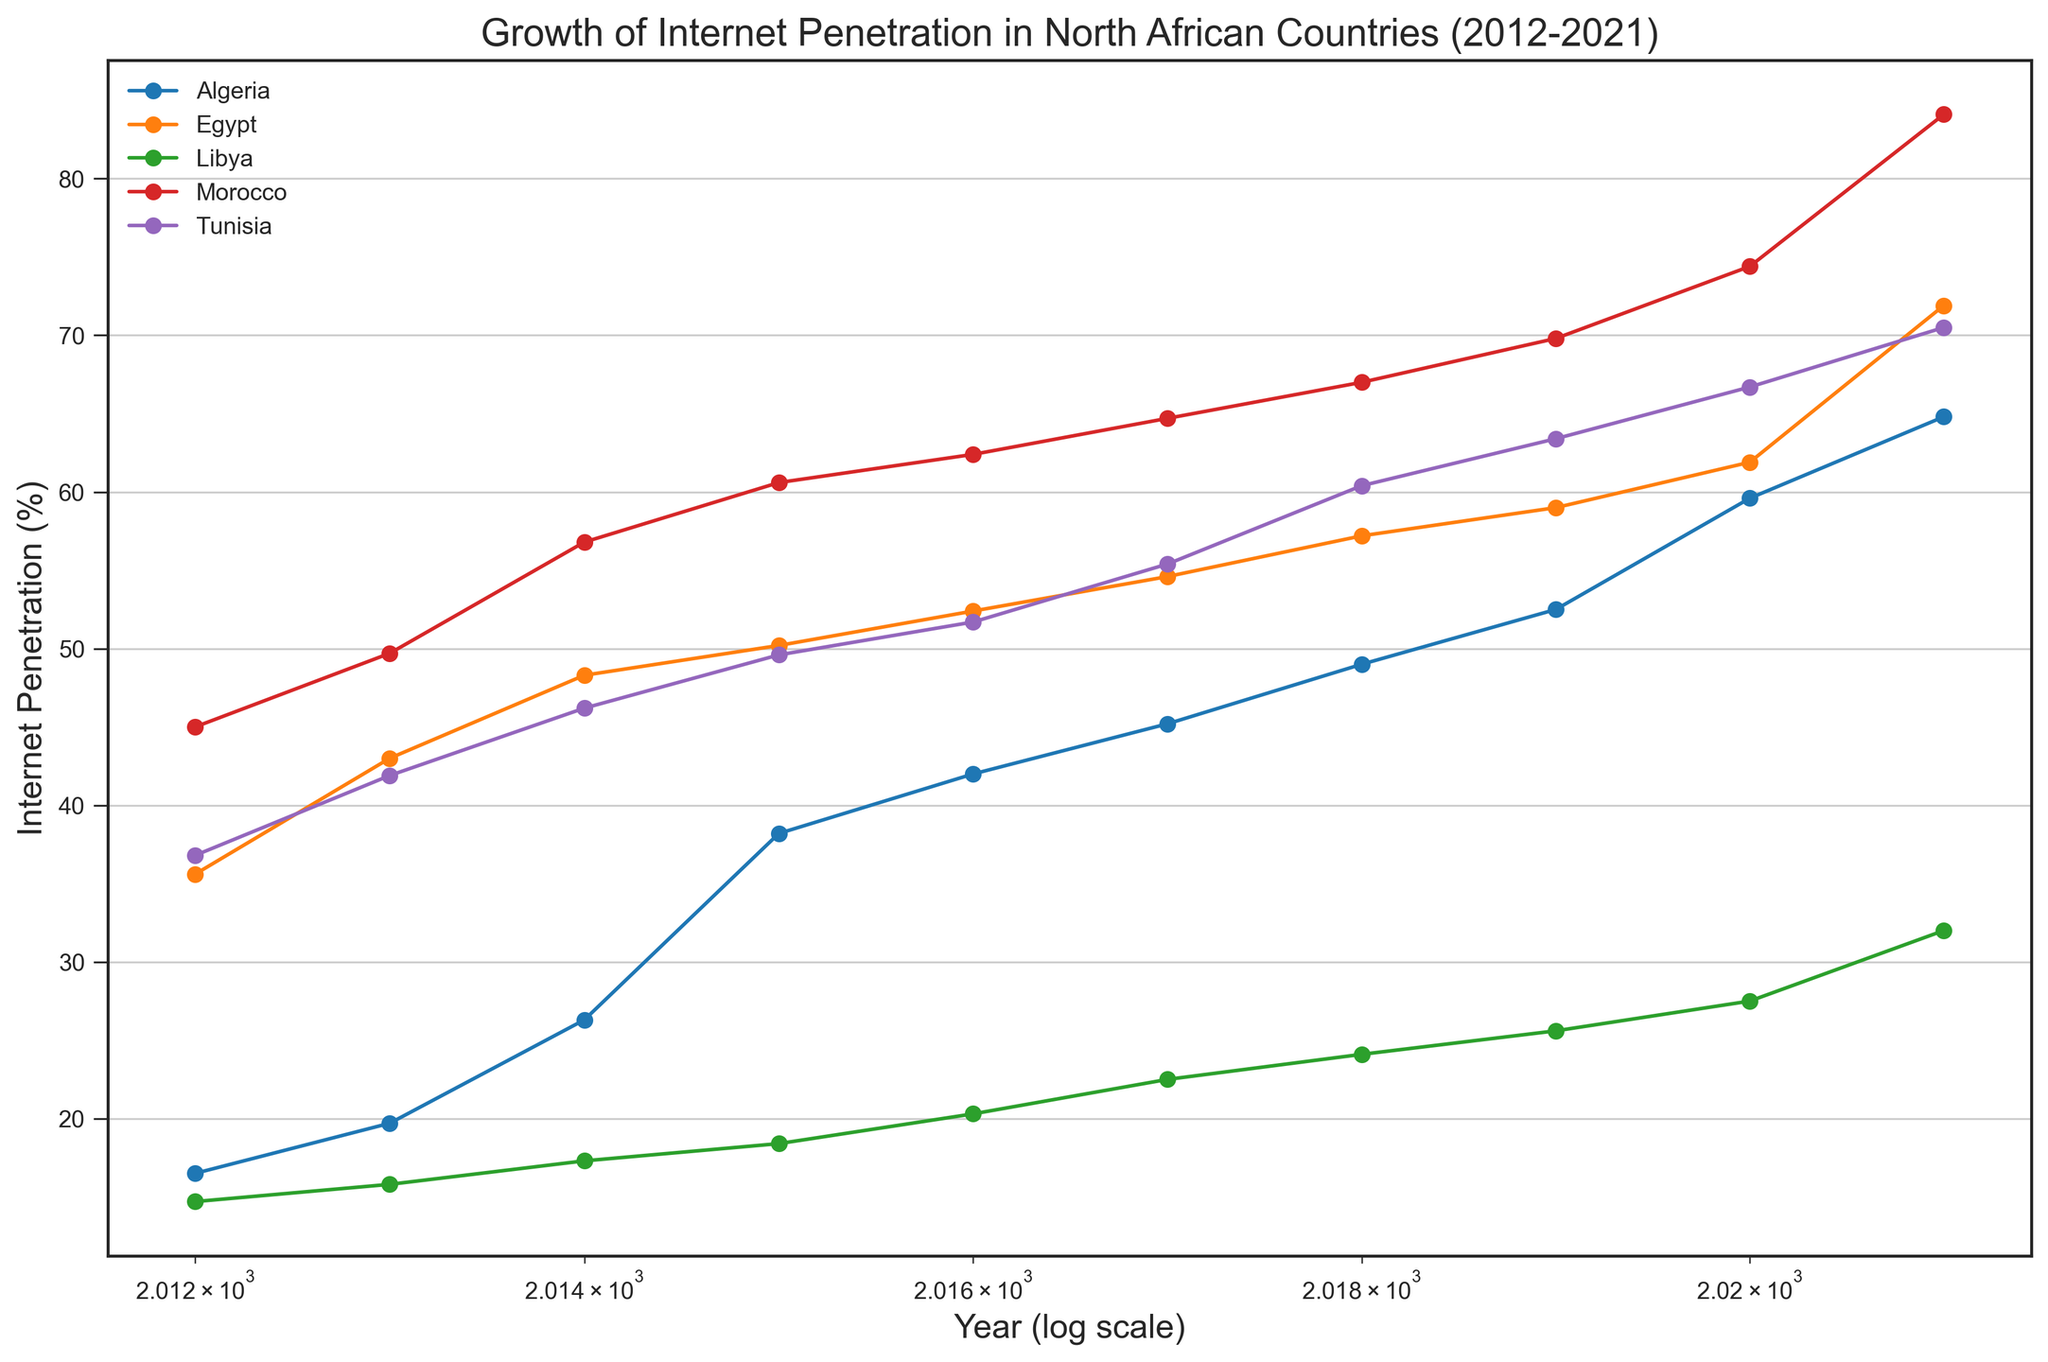Which country had the highest internet penetration percentage in 2021? Look for the country with the highest data point in 2021. According to the figure, the highest internet penetration percentage in 2021 is Morocco.
Answer: Morocco What was the approximate increase in Egypt's internet penetration percentage from 2012 to 2021? Subtract Egypt's internet penetration percentage in 2012 (35.6%) from that in 2021 (71.9%). The increase is 71.9 - 35.6 = 36.3%.
Answer: 36.3% Which country had the lowest internet penetration percentage in 2015? Locate the data points for each country in 2015 and identify the lowest value. Libya had the lowest internet penetration percentage in 2015 at 18.4%.
Answer: Libya Between 2012 and 2021, which country showed the most consistent growth in internet penetration (least fluctuations)? Visually inspect each country's trend and identify the one with the smoothest, most consistent line. Libya's line represents the most consistent growth trend with fewer fluctuations.
Answer: Libya What is the average internet penetration percentage for Tunisia in 2015, 2016, and 2017? Sum the percentages for Tunisia in 2015 (49.6%), 2016 (51.7%), and 2017 (55.4%) and divide by 3. The average is (49.6 + 51.7 + 55.4) / 3 ≈ 52.23%.
Answer: 52.23% Which countries surpassed an internet penetration percentage of 70% by 2021? Identify countries with data points exceeding 70% in 2021. Morocco (84.1%), Egypt (71.9%), and Tunisia (70.5%) all surpassed 70% by 2021.
Answer: Morocco, Egypt, Tunisia In which year did Algeria's internet penetration percentage surpass 50%? Find the year where Algeria's data point first exceeds 50%. According to the graph, it happens in 2019.
Answer: 2019 Which country had the smallest increase in internet penetration percentage from 2012 to 2021? Calculate the difference for each country and compare them. Libya had the smallest increase from 14.7% in 2012 to 32% in 2021, which is an increase of 32 - 14.7 = 17.3%.
Answer: Libya Compare the internet penetration percentage of Morocco and Tunisia in 2012. Which one was higher and by how much? Check the data points for both countries in 2012. Morocco had 45%, while Tunisia had 36.8%. The difference is 45 - 36.8 = 8.2%.
Answer: Morocco, 8.2% What was the average growth rate of internet penetration in Algeria between 2018 and 2021? Calculate the differences in internet penetration percentages for successive years from 2018 to 2021, then average them. The values are (52.5 - 49.0) = 3.5, (59.6 - 52.5) = 7.1, (64.8 - 59.6) = 5.2. The average growth rate is (3.5 + 7.1 + 5.2) / 3 ≈ 5.27%.
Answer: 5.27% 